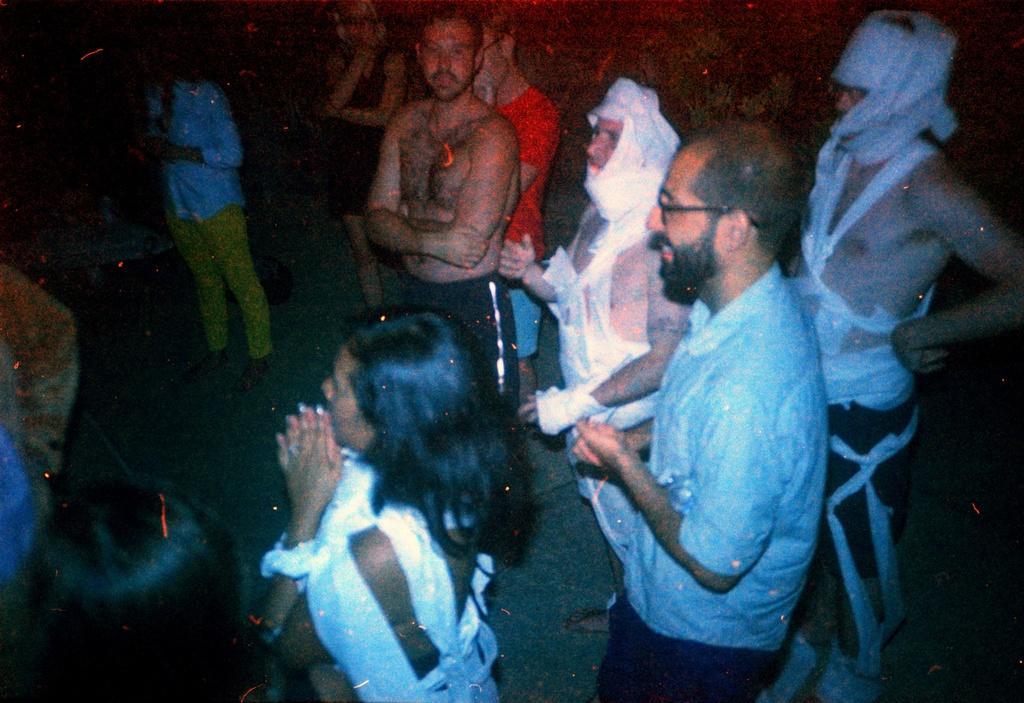How would you summarize this image in a sentence or two? In this picture we can see a group of people standing. Behind the people there is the dark background. 